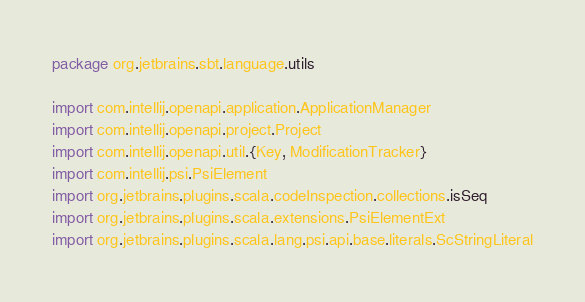<code> <loc_0><loc_0><loc_500><loc_500><_Scala_>package org.jetbrains.sbt.language.utils

import com.intellij.openapi.application.ApplicationManager
import com.intellij.openapi.project.Project
import com.intellij.openapi.util.{Key, ModificationTracker}
import com.intellij.psi.PsiElement
import org.jetbrains.plugins.scala.codeInspection.collections.isSeq
import org.jetbrains.plugins.scala.extensions.PsiElementExt
import org.jetbrains.plugins.scala.lang.psi.api.base.literals.ScStringLiteral</code> 